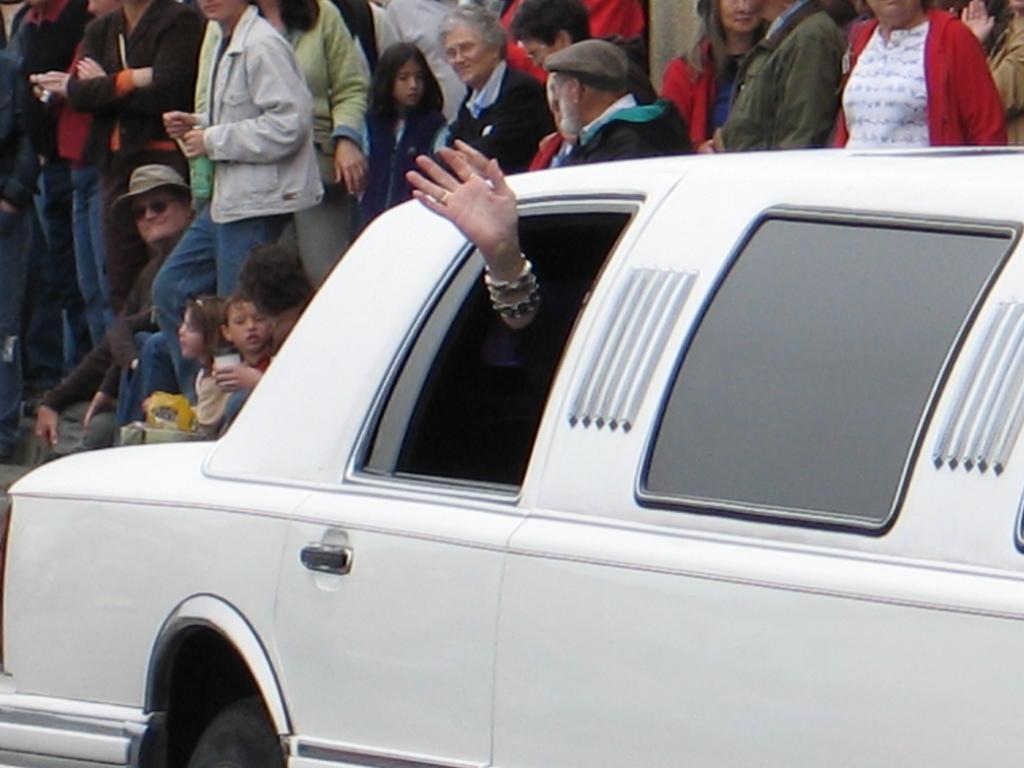In one or two sentences, can you explain what this image depicts? In this image there is a car. There is a hand of a person waving from the car. Behind the car there are many people standing and a few people sitting. 